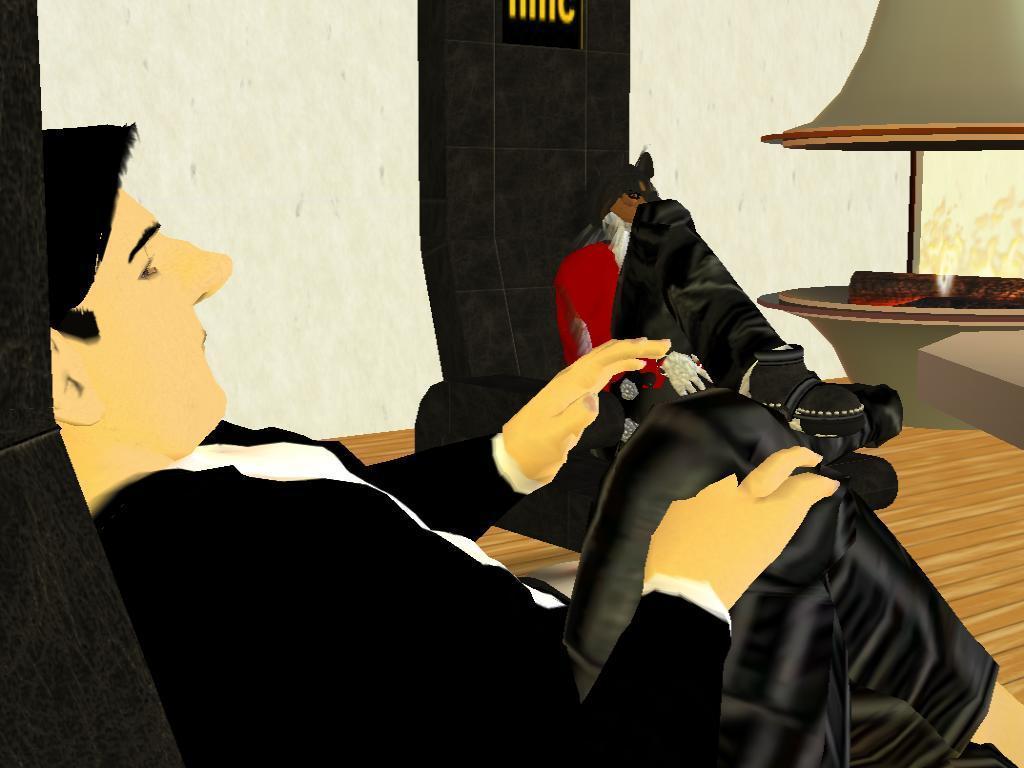How would you summarize this image in a sentence or two? This is an animated image. In the image there is a man sitting. Beside him there is another person sitting. In the background there is a table with an object. Behind the table there is a window and also there is a roof. 